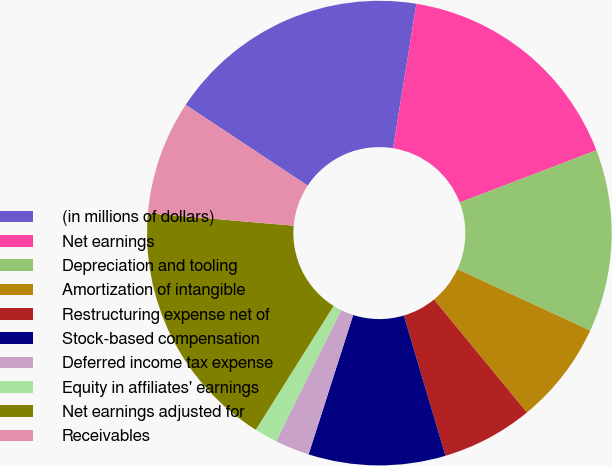<chart> <loc_0><loc_0><loc_500><loc_500><pie_chart><fcel>(in millions of dollars)<fcel>Net earnings<fcel>Depreciation and tooling<fcel>Amortization of intangible<fcel>Restructuring expense net of<fcel>Stock-based compensation<fcel>Deferred income tax expense<fcel>Equity in affiliates' earnings<fcel>Net earnings adjusted for<fcel>Receivables<nl><fcel>18.24%<fcel>16.65%<fcel>12.69%<fcel>7.15%<fcel>6.36%<fcel>9.52%<fcel>2.4%<fcel>1.6%<fcel>17.44%<fcel>7.94%<nl></chart> 